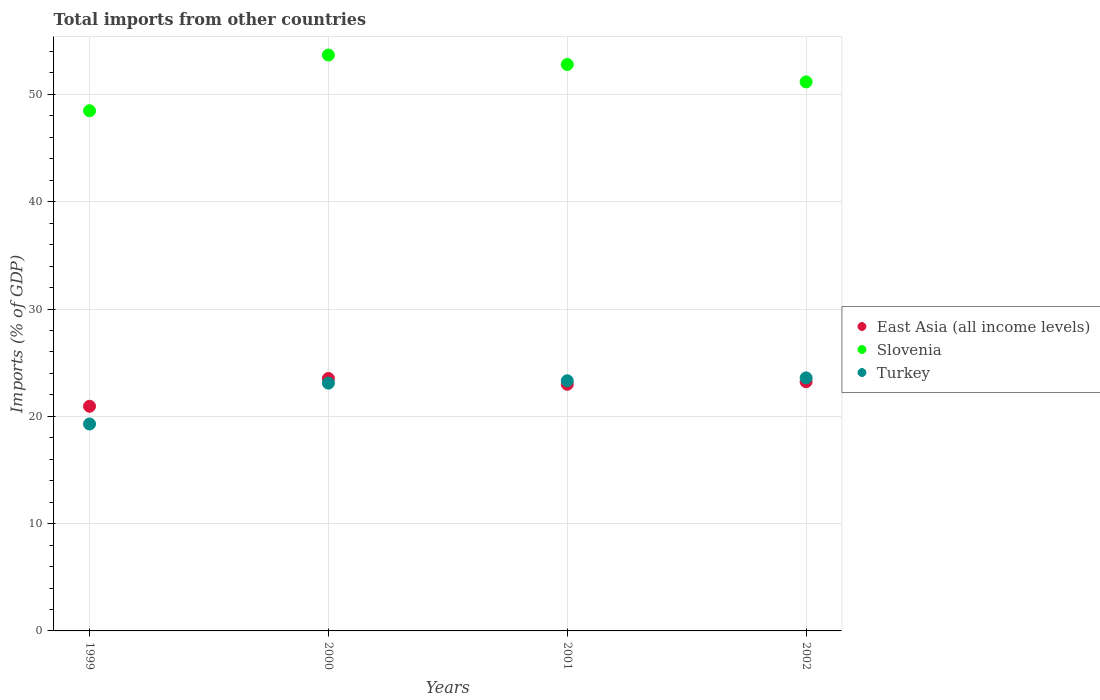Is the number of dotlines equal to the number of legend labels?
Provide a succinct answer. Yes. What is the total imports in Turkey in 2002?
Your answer should be very brief. 23.58. Across all years, what is the maximum total imports in East Asia (all income levels)?
Offer a very short reply. 23.53. Across all years, what is the minimum total imports in Slovenia?
Provide a succinct answer. 48.48. In which year was the total imports in East Asia (all income levels) maximum?
Provide a short and direct response. 2000. What is the total total imports in Turkey in the graph?
Keep it short and to the point. 89.28. What is the difference between the total imports in Turkey in 1999 and that in 2000?
Offer a very short reply. -3.81. What is the difference between the total imports in Slovenia in 2002 and the total imports in Turkey in 2000?
Make the answer very short. 28.08. What is the average total imports in Turkey per year?
Make the answer very short. 22.32. In the year 1999, what is the difference between the total imports in Slovenia and total imports in East Asia (all income levels)?
Ensure brevity in your answer.  27.54. In how many years, is the total imports in Slovenia greater than 12 %?
Your answer should be very brief. 4. What is the ratio of the total imports in Slovenia in 2001 to that in 2002?
Make the answer very short. 1.03. What is the difference between the highest and the second highest total imports in Slovenia?
Offer a very short reply. 0.88. What is the difference between the highest and the lowest total imports in Turkey?
Your response must be concise. 4.3. In how many years, is the total imports in Slovenia greater than the average total imports in Slovenia taken over all years?
Make the answer very short. 2. Is the sum of the total imports in Slovenia in 2000 and 2001 greater than the maximum total imports in Turkey across all years?
Give a very brief answer. Yes. Is it the case that in every year, the sum of the total imports in Slovenia and total imports in East Asia (all income levels)  is greater than the total imports in Turkey?
Ensure brevity in your answer.  Yes. Is the total imports in East Asia (all income levels) strictly greater than the total imports in Slovenia over the years?
Your answer should be very brief. No. Is the total imports in East Asia (all income levels) strictly less than the total imports in Turkey over the years?
Provide a succinct answer. No. How many dotlines are there?
Ensure brevity in your answer.  3. What is the difference between two consecutive major ticks on the Y-axis?
Your response must be concise. 10. Does the graph contain any zero values?
Give a very brief answer. No. Does the graph contain grids?
Provide a short and direct response. Yes. What is the title of the graph?
Offer a very short reply. Total imports from other countries. What is the label or title of the X-axis?
Offer a very short reply. Years. What is the label or title of the Y-axis?
Offer a terse response. Imports (% of GDP). What is the Imports (% of GDP) of East Asia (all income levels) in 1999?
Give a very brief answer. 20.94. What is the Imports (% of GDP) of Slovenia in 1999?
Give a very brief answer. 48.48. What is the Imports (% of GDP) in Turkey in 1999?
Your answer should be compact. 19.29. What is the Imports (% of GDP) of East Asia (all income levels) in 2000?
Provide a succinct answer. 23.53. What is the Imports (% of GDP) in Slovenia in 2000?
Offer a very short reply. 53.67. What is the Imports (% of GDP) in Turkey in 2000?
Give a very brief answer. 23.09. What is the Imports (% of GDP) in East Asia (all income levels) in 2001?
Provide a short and direct response. 22.99. What is the Imports (% of GDP) in Slovenia in 2001?
Give a very brief answer. 52.79. What is the Imports (% of GDP) of Turkey in 2001?
Offer a very short reply. 23.32. What is the Imports (% of GDP) in East Asia (all income levels) in 2002?
Offer a terse response. 23.23. What is the Imports (% of GDP) in Slovenia in 2002?
Provide a succinct answer. 51.17. What is the Imports (% of GDP) of Turkey in 2002?
Give a very brief answer. 23.58. Across all years, what is the maximum Imports (% of GDP) of East Asia (all income levels)?
Keep it short and to the point. 23.53. Across all years, what is the maximum Imports (% of GDP) in Slovenia?
Ensure brevity in your answer.  53.67. Across all years, what is the maximum Imports (% of GDP) of Turkey?
Keep it short and to the point. 23.58. Across all years, what is the minimum Imports (% of GDP) in East Asia (all income levels)?
Offer a terse response. 20.94. Across all years, what is the minimum Imports (% of GDP) of Slovenia?
Provide a short and direct response. 48.48. Across all years, what is the minimum Imports (% of GDP) of Turkey?
Offer a very short reply. 19.29. What is the total Imports (% of GDP) of East Asia (all income levels) in the graph?
Keep it short and to the point. 90.68. What is the total Imports (% of GDP) in Slovenia in the graph?
Your answer should be compact. 206.11. What is the total Imports (% of GDP) in Turkey in the graph?
Offer a terse response. 89.28. What is the difference between the Imports (% of GDP) in East Asia (all income levels) in 1999 and that in 2000?
Ensure brevity in your answer.  -2.59. What is the difference between the Imports (% of GDP) in Slovenia in 1999 and that in 2000?
Your answer should be very brief. -5.19. What is the difference between the Imports (% of GDP) of Turkey in 1999 and that in 2000?
Ensure brevity in your answer.  -3.81. What is the difference between the Imports (% of GDP) of East Asia (all income levels) in 1999 and that in 2001?
Your answer should be very brief. -2.05. What is the difference between the Imports (% of GDP) of Slovenia in 1999 and that in 2001?
Provide a succinct answer. -4.31. What is the difference between the Imports (% of GDP) in Turkey in 1999 and that in 2001?
Offer a very short reply. -4.03. What is the difference between the Imports (% of GDP) of East Asia (all income levels) in 1999 and that in 2002?
Give a very brief answer. -2.29. What is the difference between the Imports (% of GDP) in Slovenia in 1999 and that in 2002?
Give a very brief answer. -2.69. What is the difference between the Imports (% of GDP) in Turkey in 1999 and that in 2002?
Make the answer very short. -4.3. What is the difference between the Imports (% of GDP) in East Asia (all income levels) in 2000 and that in 2001?
Make the answer very short. 0.54. What is the difference between the Imports (% of GDP) in Slovenia in 2000 and that in 2001?
Offer a terse response. 0.88. What is the difference between the Imports (% of GDP) in Turkey in 2000 and that in 2001?
Your response must be concise. -0.22. What is the difference between the Imports (% of GDP) of East Asia (all income levels) in 2000 and that in 2002?
Give a very brief answer. 0.3. What is the difference between the Imports (% of GDP) of Slovenia in 2000 and that in 2002?
Your answer should be very brief. 2.5. What is the difference between the Imports (% of GDP) in Turkey in 2000 and that in 2002?
Make the answer very short. -0.49. What is the difference between the Imports (% of GDP) of East Asia (all income levels) in 2001 and that in 2002?
Provide a succinct answer. -0.24. What is the difference between the Imports (% of GDP) of Slovenia in 2001 and that in 2002?
Your answer should be very brief. 1.62. What is the difference between the Imports (% of GDP) in Turkey in 2001 and that in 2002?
Keep it short and to the point. -0.27. What is the difference between the Imports (% of GDP) in East Asia (all income levels) in 1999 and the Imports (% of GDP) in Slovenia in 2000?
Your response must be concise. -32.74. What is the difference between the Imports (% of GDP) of East Asia (all income levels) in 1999 and the Imports (% of GDP) of Turkey in 2000?
Offer a very short reply. -2.16. What is the difference between the Imports (% of GDP) of Slovenia in 1999 and the Imports (% of GDP) of Turkey in 2000?
Keep it short and to the point. 25.39. What is the difference between the Imports (% of GDP) in East Asia (all income levels) in 1999 and the Imports (% of GDP) in Slovenia in 2001?
Keep it short and to the point. -31.85. What is the difference between the Imports (% of GDP) in East Asia (all income levels) in 1999 and the Imports (% of GDP) in Turkey in 2001?
Give a very brief answer. -2.38. What is the difference between the Imports (% of GDP) of Slovenia in 1999 and the Imports (% of GDP) of Turkey in 2001?
Keep it short and to the point. 25.17. What is the difference between the Imports (% of GDP) of East Asia (all income levels) in 1999 and the Imports (% of GDP) of Slovenia in 2002?
Ensure brevity in your answer.  -30.23. What is the difference between the Imports (% of GDP) in East Asia (all income levels) in 1999 and the Imports (% of GDP) in Turkey in 2002?
Your response must be concise. -2.64. What is the difference between the Imports (% of GDP) of Slovenia in 1999 and the Imports (% of GDP) of Turkey in 2002?
Keep it short and to the point. 24.9. What is the difference between the Imports (% of GDP) of East Asia (all income levels) in 2000 and the Imports (% of GDP) of Slovenia in 2001?
Keep it short and to the point. -29.26. What is the difference between the Imports (% of GDP) in East Asia (all income levels) in 2000 and the Imports (% of GDP) in Turkey in 2001?
Ensure brevity in your answer.  0.21. What is the difference between the Imports (% of GDP) in Slovenia in 2000 and the Imports (% of GDP) in Turkey in 2001?
Your answer should be compact. 30.36. What is the difference between the Imports (% of GDP) of East Asia (all income levels) in 2000 and the Imports (% of GDP) of Slovenia in 2002?
Provide a succinct answer. -27.64. What is the difference between the Imports (% of GDP) of East Asia (all income levels) in 2000 and the Imports (% of GDP) of Turkey in 2002?
Your answer should be very brief. -0.05. What is the difference between the Imports (% of GDP) in Slovenia in 2000 and the Imports (% of GDP) in Turkey in 2002?
Make the answer very short. 30.09. What is the difference between the Imports (% of GDP) in East Asia (all income levels) in 2001 and the Imports (% of GDP) in Slovenia in 2002?
Your answer should be very brief. -28.18. What is the difference between the Imports (% of GDP) of East Asia (all income levels) in 2001 and the Imports (% of GDP) of Turkey in 2002?
Make the answer very short. -0.6. What is the difference between the Imports (% of GDP) of Slovenia in 2001 and the Imports (% of GDP) of Turkey in 2002?
Offer a very short reply. 29.21. What is the average Imports (% of GDP) of East Asia (all income levels) per year?
Your response must be concise. 22.67. What is the average Imports (% of GDP) of Slovenia per year?
Your answer should be compact. 51.53. What is the average Imports (% of GDP) in Turkey per year?
Make the answer very short. 22.32. In the year 1999, what is the difference between the Imports (% of GDP) of East Asia (all income levels) and Imports (% of GDP) of Slovenia?
Offer a terse response. -27.54. In the year 1999, what is the difference between the Imports (% of GDP) in East Asia (all income levels) and Imports (% of GDP) in Turkey?
Provide a short and direct response. 1.65. In the year 1999, what is the difference between the Imports (% of GDP) of Slovenia and Imports (% of GDP) of Turkey?
Your response must be concise. 29.2. In the year 2000, what is the difference between the Imports (% of GDP) in East Asia (all income levels) and Imports (% of GDP) in Slovenia?
Ensure brevity in your answer.  -30.14. In the year 2000, what is the difference between the Imports (% of GDP) in East Asia (all income levels) and Imports (% of GDP) in Turkey?
Make the answer very short. 0.43. In the year 2000, what is the difference between the Imports (% of GDP) in Slovenia and Imports (% of GDP) in Turkey?
Your answer should be compact. 30.58. In the year 2001, what is the difference between the Imports (% of GDP) of East Asia (all income levels) and Imports (% of GDP) of Slovenia?
Your response must be concise. -29.8. In the year 2001, what is the difference between the Imports (% of GDP) in East Asia (all income levels) and Imports (% of GDP) in Turkey?
Offer a terse response. -0.33. In the year 2001, what is the difference between the Imports (% of GDP) of Slovenia and Imports (% of GDP) of Turkey?
Provide a succinct answer. 29.47. In the year 2002, what is the difference between the Imports (% of GDP) in East Asia (all income levels) and Imports (% of GDP) in Slovenia?
Give a very brief answer. -27.94. In the year 2002, what is the difference between the Imports (% of GDP) in East Asia (all income levels) and Imports (% of GDP) in Turkey?
Make the answer very short. -0.35. In the year 2002, what is the difference between the Imports (% of GDP) of Slovenia and Imports (% of GDP) of Turkey?
Keep it short and to the point. 27.59. What is the ratio of the Imports (% of GDP) of East Asia (all income levels) in 1999 to that in 2000?
Offer a terse response. 0.89. What is the ratio of the Imports (% of GDP) in Slovenia in 1999 to that in 2000?
Provide a short and direct response. 0.9. What is the ratio of the Imports (% of GDP) of Turkey in 1999 to that in 2000?
Provide a short and direct response. 0.84. What is the ratio of the Imports (% of GDP) of East Asia (all income levels) in 1999 to that in 2001?
Your answer should be compact. 0.91. What is the ratio of the Imports (% of GDP) in Slovenia in 1999 to that in 2001?
Offer a very short reply. 0.92. What is the ratio of the Imports (% of GDP) in Turkey in 1999 to that in 2001?
Provide a succinct answer. 0.83. What is the ratio of the Imports (% of GDP) in East Asia (all income levels) in 1999 to that in 2002?
Provide a short and direct response. 0.9. What is the ratio of the Imports (% of GDP) in Slovenia in 1999 to that in 2002?
Ensure brevity in your answer.  0.95. What is the ratio of the Imports (% of GDP) in Turkey in 1999 to that in 2002?
Ensure brevity in your answer.  0.82. What is the ratio of the Imports (% of GDP) of East Asia (all income levels) in 2000 to that in 2001?
Your response must be concise. 1.02. What is the ratio of the Imports (% of GDP) in Slovenia in 2000 to that in 2001?
Your answer should be compact. 1.02. What is the ratio of the Imports (% of GDP) in Turkey in 2000 to that in 2001?
Give a very brief answer. 0.99. What is the ratio of the Imports (% of GDP) in East Asia (all income levels) in 2000 to that in 2002?
Keep it short and to the point. 1.01. What is the ratio of the Imports (% of GDP) of Slovenia in 2000 to that in 2002?
Make the answer very short. 1.05. What is the ratio of the Imports (% of GDP) of Turkey in 2000 to that in 2002?
Your answer should be very brief. 0.98. What is the ratio of the Imports (% of GDP) in Slovenia in 2001 to that in 2002?
Your response must be concise. 1.03. What is the ratio of the Imports (% of GDP) of Turkey in 2001 to that in 2002?
Provide a short and direct response. 0.99. What is the difference between the highest and the second highest Imports (% of GDP) of East Asia (all income levels)?
Make the answer very short. 0.3. What is the difference between the highest and the second highest Imports (% of GDP) of Slovenia?
Your answer should be very brief. 0.88. What is the difference between the highest and the second highest Imports (% of GDP) of Turkey?
Offer a very short reply. 0.27. What is the difference between the highest and the lowest Imports (% of GDP) of East Asia (all income levels)?
Offer a terse response. 2.59. What is the difference between the highest and the lowest Imports (% of GDP) in Slovenia?
Provide a short and direct response. 5.19. What is the difference between the highest and the lowest Imports (% of GDP) in Turkey?
Ensure brevity in your answer.  4.3. 